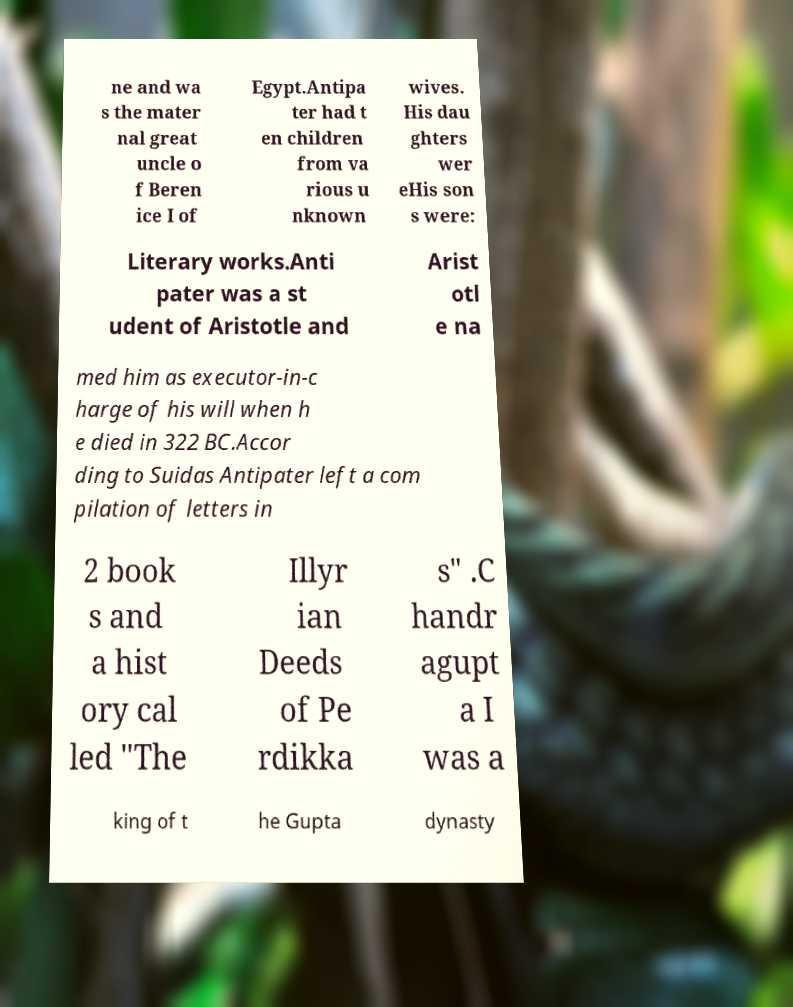Can you read and provide the text displayed in the image?This photo seems to have some interesting text. Can you extract and type it out for me? ne and wa s the mater nal great uncle o f Beren ice I of Egypt.Antipa ter had t en children from va rious u nknown wives. His dau ghters wer eHis son s were: Literary works.Anti pater was a st udent of Aristotle and Arist otl e na med him as executor-in-c harge of his will when h e died in 322 BC.Accor ding to Suidas Antipater left a com pilation of letters in 2 book s and a hist ory cal led "The Illyr ian Deeds of Pe rdikka s" .C handr agupt a I was a king of t he Gupta dynasty 